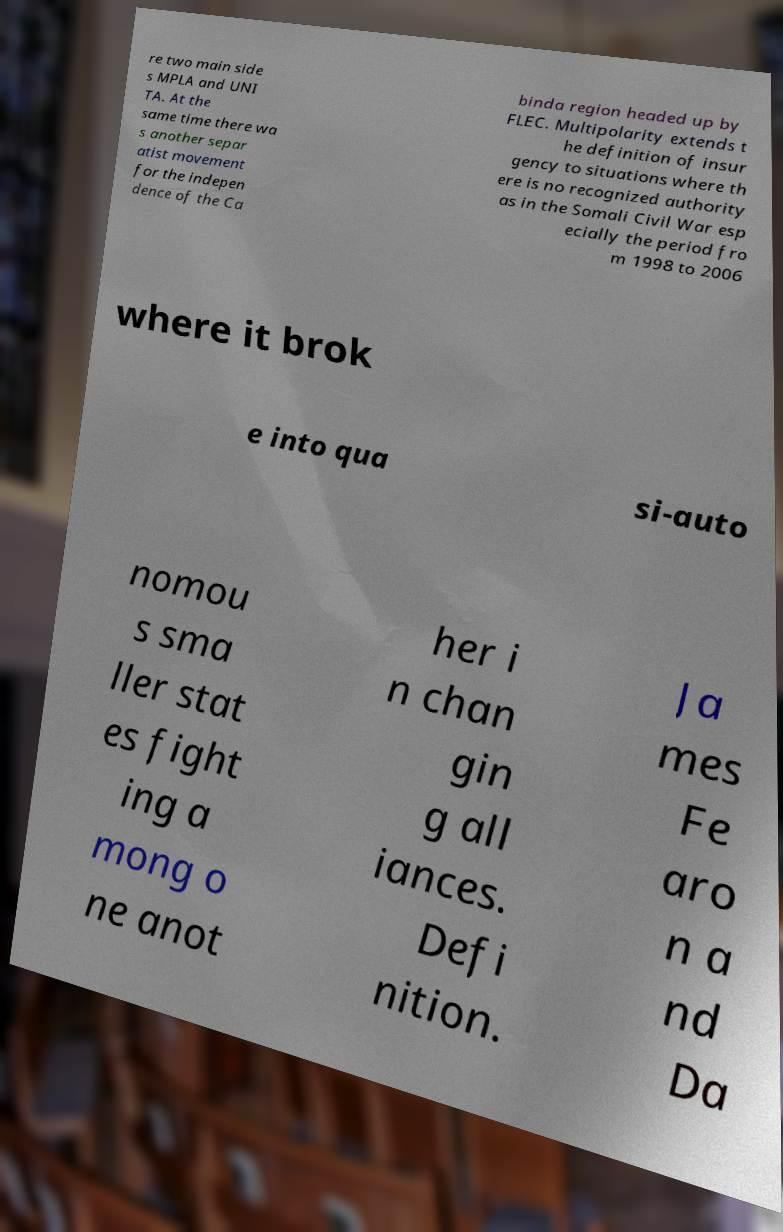Could you extract and type out the text from this image? re two main side s MPLA and UNI TA. At the same time there wa s another separ atist movement for the indepen dence of the Ca binda region headed up by FLEC. Multipolarity extends t he definition of insur gency to situations where th ere is no recognized authority as in the Somali Civil War esp ecially the period fro m 1998 to 2006 where it brok e into qua si-auto nomou s sma ller stat es fight ing a mong o ne anot her i n chan gin g all iances. Defi nition. Ja mes Fe aro n a nd Da 